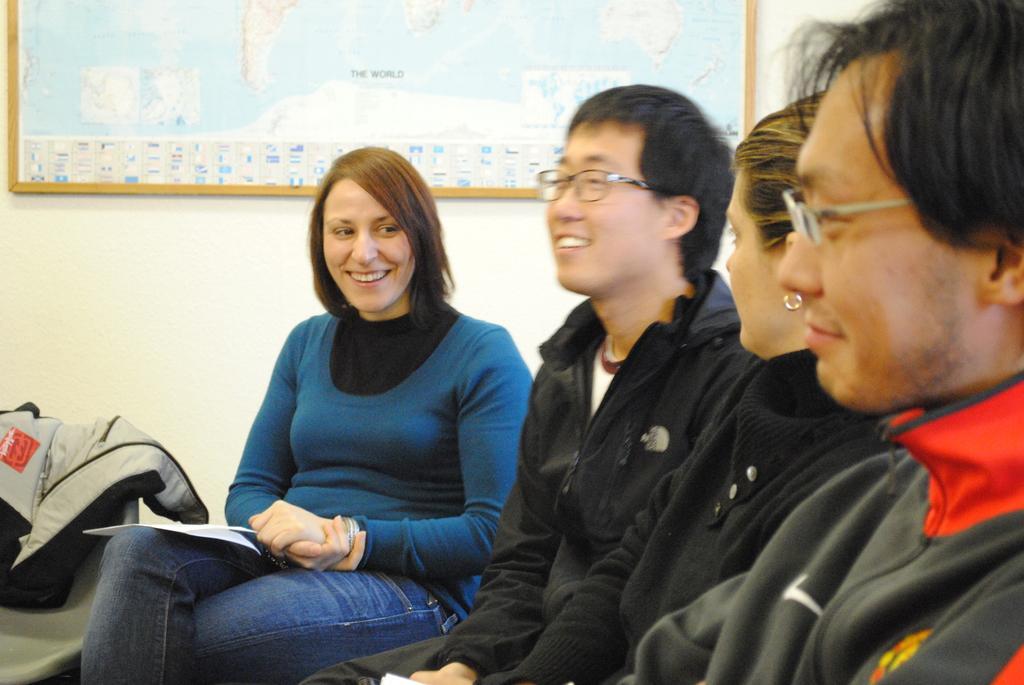How would you summarize this image in a sentence or two? In this picture I can see few people are sitting and also I can see a frame to the wall. 